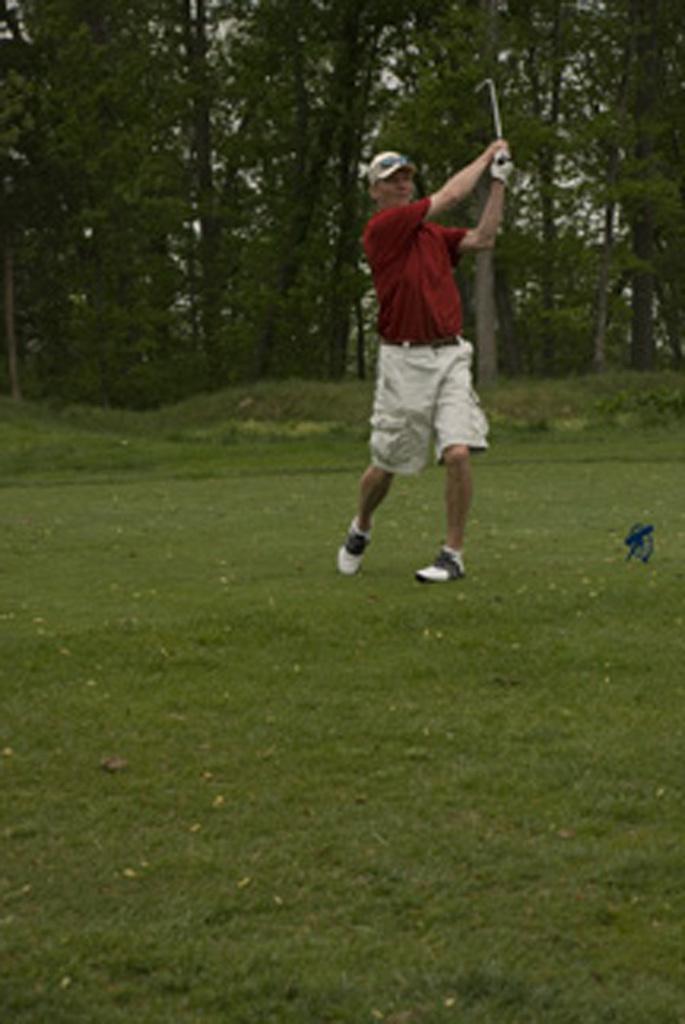In one or two sentences, can you explain what this image depicts? In this picture, we can see a person holding an object, and we can see the ground with grass, and a few trees. 